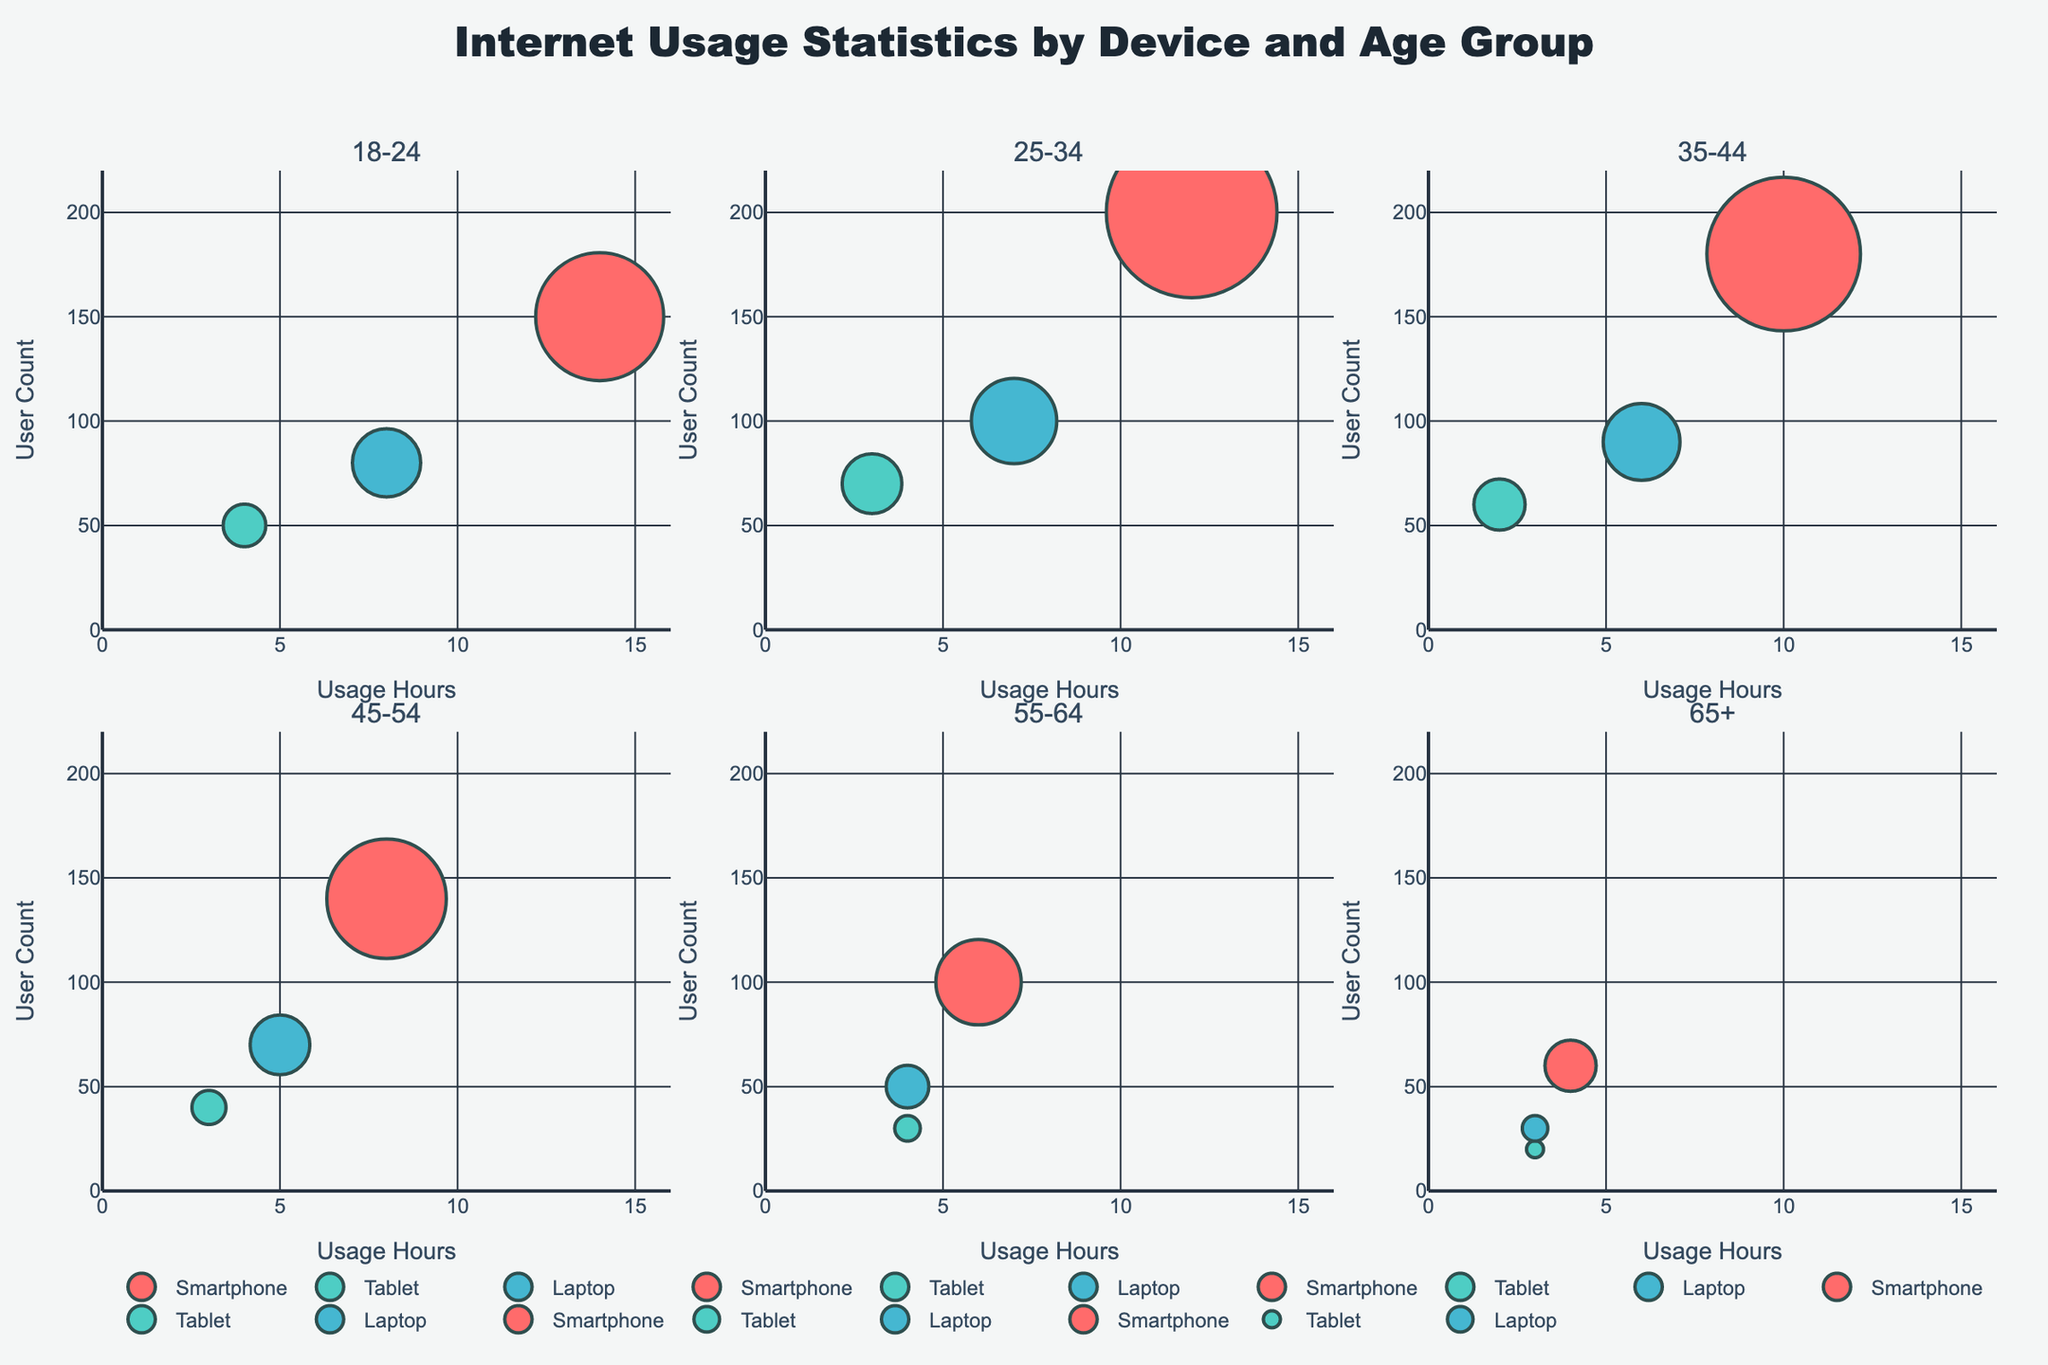What's the title of the plot? The title of the plot is displayed prominently at the top of the figure, aiming to give an overview of the data visualized. By reading it directly, we see it clearly states "Internet Usage Statistics by Device and Age Group".
Answer: Internet Usage Statistics by Device and Age Group What is the range of the x-axis across all subplots? By examining the axis labels in each subplot, we can see the x-axis range is consistent. The x-axis, labeled as 'Usage Hours', ranges from 0 to 16 hours in all subplots.
Answer: 0 to 16 Which device has the highest user count in the age group 25-34? Looking at the subplot for the age group 25-34, we notice three distinct bubble sizes representing different devices. The largest bubble, indicating the highest user count, corresponds to the Smartphone.
Answer: Smartphone What is the sum of user counts for all devices in the age group 18-24? We sum up the user counts for Smartphone, Tablet, and Laptop in the 18-24 age group: 150 (Smartphone) + 50 (Tablet) + 80 (Laptop).
Answer: 280 Which age group has the largest bubble for Laptop usage? Comparing bubble sizes across subplots for the Laptop device, the largest bubble appears in the age group 25-34.
Answer: 25-34 What is the difference in user count between Tablet and Laptop in the age group 35-44? Subtracting the user count for Laptop (90) from Tablet (60) within the 35-44 age group gives us 60 - 90 = -30. Therefore, the difference is 30 users.
Answer: 30 users Which device has the same usage hours across the most age groups? Observing the x-axis positions of bubbles across the subplots, we notice that both Tablet and Laptop have consistent usage hours in most age groups, at 3-4 and 3-7 hours respectively. However, all data points for Tablet usage are at 3-4 hours.
Answer: Tablet In the age group 65+, which device has the lowest number of usage hours? Analyzing the x-axis positions in the 65+ age group subplot, the Laptop shows the lowest usage hours at 3 hours.
Answer: Laptop 